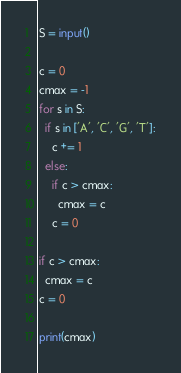<code> <loc_0><loc_0><loc_500><loc_500><_Python_>S = input()

c = 0
cmax = -1
for s in S:
  if s in ['A', 'C', 'G', 'T']:
    c += 1
  else:
    if c > cmax:
      cmax = c
    c = 0
    
if c > cmax:
  cmax = c
c = 0

print(cmax)</code> 